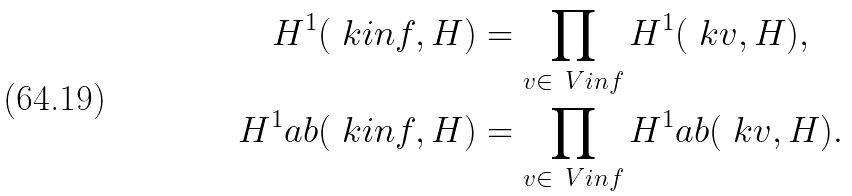<formula> <loc_0><loc_0><loc_500><loc_500>H ^ { 1 } ( \ k i n f , H ) & = \prod _ { v \in \ V i n f } H ^ { 1 } ( \ k v , H ) , \\ H ^ { 1 } _ { \ } a b ( \ k i n f , H ) & = \prod _ { v \in \ V i n f } H ^ { 1 } _ { \ } a b ( \ k v , H ) .</formula> 